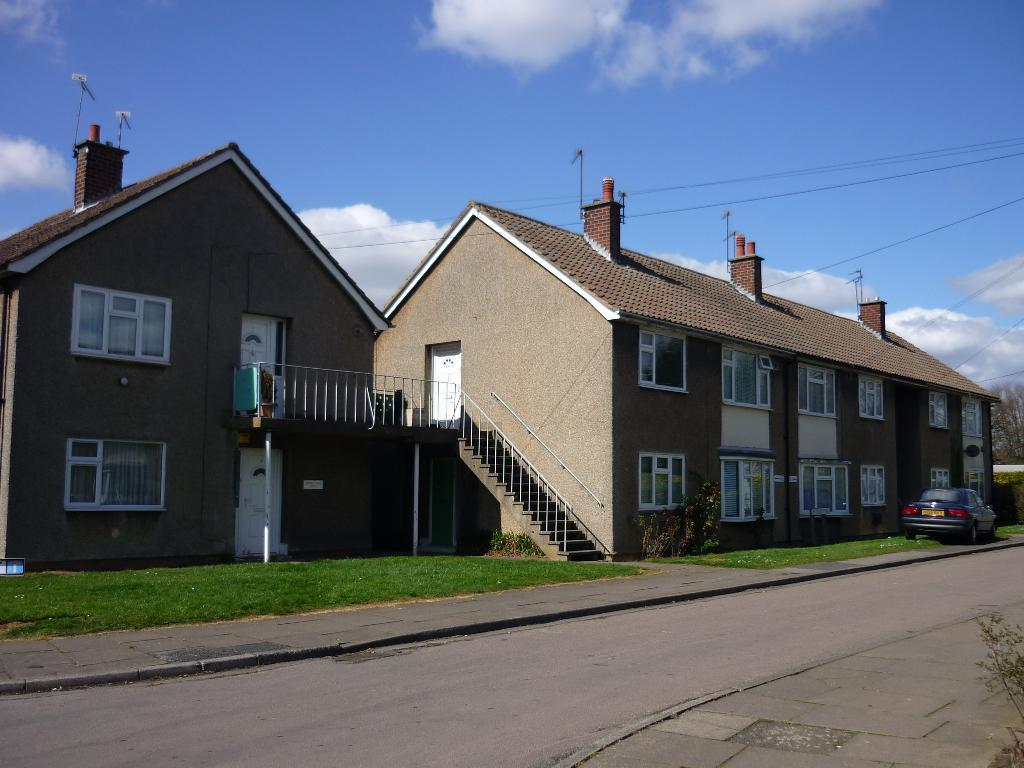What type of structures can be seen in the image? There are buildings in the image. What mode of transportation is visible in the image? There is a car in the image. What type of vegetation is present in the image? There is grass in the image. What type of infrastructure is present in the image? Cables are present in the image. What type of pathway is visible in the image? There is a road in the image. What type of living organism is present in the image? There is a plant in the image. What part of the natural environment is visible in the image? The sky is visible in the image. What type of weather can be inferred from the image? Clouds are present in the sky, suggesting that it might be a partly cloudy day. What type of cherry is being offered by the plant in the image? There is no cherry present in the image, and the plant is not offering anything. What type of cable is being used to connect the buildings in the image? The image does not provide enough detail to determine the type of cable being used to connect the buildings. 